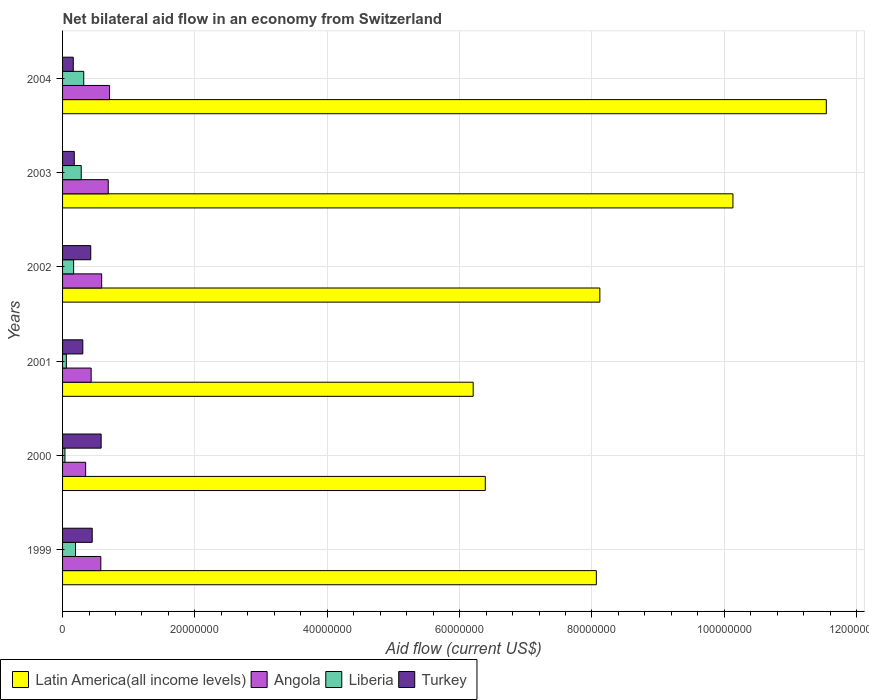How many bars are there on the 4th tick from the top?
Provide a short and direct response. 4. In how many cases, is the number of bars for a given year not equal to the number of legend labels?
Offer a terse response. 0. What is the net bilateral aid flow in Liberia in 2002?
Offer a terse response. 1.67e+06. Across all years, what is the maximum net bilateral aid flow in Angola?
Keep it short and to the point. 7.10e+06. Across all years, what is the minimum net bilateral aid flow in Angola?
Your response must be concise. 3.49e+06. In which year was the net bilateral aid flow in Angola maximum?
Offer a very short reply. 2004. In which year was the net bilateral aid flow in Angola minimum?
Offer a terse response. 2000. What is the total net bilateral aid flow in Angola in the graph?
Give a very brief answer. 3.35e+07. What is the difference between the net bilateral aid flow in Liberia in 2000 and that in 2004?
Offer a terse response. -2.84e+06. What is the difference between the net bilateral aid flow in Angola in 2004 and the net bilateral aid flow in Latin America(all income levels) in 1999?
Your answer should be compact. -7.36e+07. What is the average net bilateral aid flow in Angola per year?
Provide a succinct answer. 5.58e+06. In the year 1999, what is the difference between the net bilateral aid flow in Turkey and net bilateral aid flow in Latin America(all income levels)?
Your answer should be compact. -7.62e+07. What is the ratio of the net bilateral aid flow in Angola in 2002 to that in 2003?
Your answer should be compact. 0.86. Is the net bilateral aid flow in Turkey in 2002 less than that in 2004?
Your answer should be compact. No. Is the difference between the net bilateral aid flow in Turkey in 2003 and 2004 greater than the difference between the net bilateral aid flow in Latin America(all income levels) in 2003 and 2004?
Offer a terse response. Yes. What is the difference between the highest and the lowest net bilateral aid flow in Latin America(all income levels)?
Make the answer very short. 5.34e+07. In how many years, is the net bilateral aid flow in Liberia greater than the average net bilateral aid flow in Liberia taken over all years?
Ensure brevity in your answer.  3. Is it the case that in every year, the sum of the net bilateral aid flow in Angola and net bilateral aid flow in Latin America(all income levels) is greater than the sum of net bilateral aid flow in Turkey and net bilateral aid flow in Liberia?
Provide a succinct answer. No. What does the 4th bar from the top in 2002 represents?
Offer a very short reply. Latin America(all income levels). What does the 2nd bar from the bottom in 1999 represents?
Ensure brevity in your answer.  Angola. Is it the case that in every year, the sum of the net bilateral aid flow in Angola and net bilateral aid flow in Liberia is greater than the net bilateral aid flow in Turkey?
Ensure brevity in your answer.  No. How many bars are there?
Your answer should be very brief. 24. How many years are there in the graph?
Your answer should be compact. 6. What is the difference between two consecutive major ticks on the X-axis?
Provide a succinct answer. 2.00e+07. Are the values on the major ticks of X-axis written in scientific E-notation?
Give a very brief answer. No. Does the graph contain any zero values?
Give a very brief answer. No. How many legend labels are there?
Provide a short and direct response. 4. How are the legend labels stacked?
Keep it short and to the point. Horizontal. What is the title of the graph?
Your answer should be very brief. Net bilateral aid flow in an economy from Switzerland. What is the label or title of the Y-axis?
Your answer should be compact. Years. What is the Aid flow (current US$) in Latin America(all income levels) in 1999?
Give a very brief answer. 8.07e+07. What is the Aid flow (current US$) in Angola in 1999?
Offer a terse response. 5.78e+06. What is the Aid flow (current US$) in Liberia in 1999?
Ensure brevity in your answer.  1.96e+06. What is the Aid flow (current US$) in Turkey in 1999?
Your answer should be compact. 4.48e+06. What is the Aid flow (current US$) in Latin America(all income levels) in 2000?
Your answer should be very brief. 6.39e+07. What is the Aid flow (current US$) of Angola in 2000?
Give a very brief answer. 3.49e+06. What is the Aid flow (current US$) in Liberia in 2000?
Offer a terse response. 3.60e+05. What is the Aid flow (current US$) of Turkey in 2000?
Offer a very short reply. 5.83e+06. What is the Aid flow (current US$) in Latin America(all income levels) in 2001?
Give a very brief answer. 6.20e+07. What is the Aid flow (current US$) of Angola in 2001?
Provide a succinct answer. 4.32e+06. What is the Aid flow (current US$) in Liberia in 2001?
Provide a succinct answer. 5.70e+05. What is the Aid flow (current US$) in Turkey in 2001?
Give a very brief answer. 3.06e+06. What is the Aid flow (current US$) in Latin America(all income levels) in 2002?
Your answer should be very brief. 8.12e+07. What is the Aid flow (current US$) in Angola in 2002?
Ensure brevity in your answer.  5.91e+06. What is the Aid flow (current US$) of Liberia in 2002?
Keep it short and to the point. 1.67e+06. What is the Aid flow (current US$) in Turkey in 2002?
Keep it short and to the point. 4.26e+06. What is the Aid flow (current US$) of Latin America(all income levels) in 2003?
Give a very brief answer. 1.01e+08. What is the Aid flow (current US$) in Angola in 2003?
Your answer should be compact. 6.90e+06. What is the Aid flow (current US$) of Liberia in 2003?
Provide a short and direct response. 2.82e+06. What is the Aid flow (current US$) of Turkey in 2003?
Keep it short and to the point. 1.77e+06. What is the Aid flow (current US$) in Latin America(all income levels) in 2004?
Your answer should be compact. 1.15e+08. What is the Aid flow (current US$) of Angola in 2004?
Your answer should be compact. 7.10e+06. What is the Aid flow (current US$) of Liberia in 2004?
Give a very brief answer. 3.20e+06. What is the Aid flow (current US$) in Turkey in 2004?
Your response must be concise. 1.62e+06. Across all years, what is the maximum Aid flow (current US$) of Latin America(all income levels)?
Your response must be concise. 1.15e+08. Across all years, what is the maximum Aid flow (current US$) in Angola?
Provide a succinct answer. 7.10e+06. Across all years, what is the maximum Aid flow (current US$) in Liberia?
Keep it short and to the point. 3.20e+06. Across all years, what is the maximum Aid flow (current US$) in Turkey?
Your answer should be compact. 5.83e+06. Across all years, what is the minimum Aid flow (current US$) of Latin America(all income levels)?
Provide a succinct answer. 6.20e+07. Across all years, what is the minimum Aid flow (current US$) of Angola?
Provide a short and direct response. 3.49e+06. Across all years, what is the minimum Aid flow (current US$) of Liberia?
Offer a very short reply. 3.60e+05. Across all years, what is the minimum Aid flow (current US$) in Turkey?
Your answer should be compact. 1.62e+06. What is the total Aid flow (current US$) of Latin America(all income levels) in the graph?
Keep it short and to the point. 5.04e+08. What is the total Aid flow (current US$) of Angola in the graph?
Offer a terse response. 3.35e+07. What is the total Aid flow (current US$) in Liberia in the graph?
Offer a terse response. 1.06e+07. What is the total Aid flow (current US$) of Turkey in the graph?
Your answer should be compact. 2.10e+07. What is the difference between the Aid flow (current US$) in Latin America(all income levels) in 1999 and that in 2000?
Your answer should be very brief. 1.68e+07. What is the difference between the Aid flow (current US$) of Angola in 1999 and that in 2000?
Ensure brevity in your answer.  2.29e+06. What is the difference between the Aid flow (current US$) in Liberia in 1999 and that in 2000?
Your answer should be very brief. 1.60e+06. What is the difference between the Aid flow (current US$) of Turkey in 1999 and that in 2000?
Offer a very short reply. -1.35e+06. What is the difference between the Aid flow (current US$) of Latin America(all income levels) in 1999 and that in 2001?
Ensure brevity in your answer.  1.86e+07. What is the difference between the Aid flow (current US$) in Angola in 1999 and that in 2001?
Your response must be concise. 1.46e+06. What is the difference between the Aid flow (current US$) in Liberia in 1999 and that in 2001?
Offer a very short reply. 1.39e+06. What is the difference between the Aid flow (current US$) in Turkey in 1999 and that in 2001?
Ensure brevity in your answer.  1.42e+06. What is the difference between the Aid flow (current US$) in Latin America(all income levels) in 1999 and that in 2002?
Make the answer very short. -5.30e+05. What is the difference between the Aid flow (current US$) in Latin America(all income levels) in 1999 and that in 2003?
Provide a succinct answer. -2.06e+07. What is the difference between the Aid flow (current US$) in Angola in 1999 and that in 2003?
Make the answer very short. -1.12e+06. What is the difference between the Aid flow (current US$) of Liberia in 1999 and that in 2003?
Offer a terse response. -8.60e+05. What is the difference between the Aid flow (current US$) of Turkey in 1999 and that in 2003?
Your response must be concise. 2.71e+06. What is the difference between the Aid flow (current US$) in Latin America(all income levels) in 1999 and that in 2004?
Offer a terse response. -3.48e+07. What is the difference between the Aid flow (current US$) in Angola in 1999 and that in 2004?
Your answer should be compact. -1.32e+06. What is the difference between the Aid flow (current US$) in Liberia in 1999 and that in 2004?
Offer a terse response. -1.24e+06. What is the difference between the Aid flow (current US$) in Turkey in 1999 and that in 2004?
Give a very brief answer. 2.86e+06. What is the difference between the Aid flow (current US$) in Latin America(all income levels) in 2000 and that in 2001?
Your answer should be compact. 1.83e+06. What is the difference between the Aid flow (current US$) in Angola in 2000 and that in 2001?
Your response must be concise. -8.30e+05. What is the difference between the Aid flow (current US$) in Liberia in 2000 and that in 2001?
Provide a succinct answer. -2.10e+05. What is the difference between the Aid flow (current US$) of Turkey in 2000 and that in 2001?
Give a very brief answer. 2.77e+06. What is the difference between the Aid flow (current US$) in Latin America(all income levels) in 2000 and that in 2002?
Your response must be concise. -1.73e+07. What is the difference between the Aid flow (current US$) in Angola in 2000 and that in 2002?
Provide a succinct answer. -2.42e+06. What is the difference between the Aid flow (current US$) of Liberia in 2000 and that in 2002?
Provide a short and direct response. -1.31e+06. What is the difference between the Aid flow (current US$) of Turkey in 2000 and that in 2002?
Keep it short and to the point. 1.57e+06. What is the difference between the Aid flow (current US$) of Latin America(all income levels) in 2000 and that in 2003?
Your answer should be compact. -3.74e+07. What is the difference between the Aid flow (current US$) in Angola in 2000 and that in 2003?
Offer a very short reply. -3.41e+06. What is the difference between the Aid flow (current US$) in Liberia in 2000 and that in 2003?
Give a very brief answer. -2.46e+06. What is the difference between the Aid flow (current US$) in Turkey in 2000 and that in 2003?
Make the answer very short. 4.06e+06. What is the difference between the Aid flow (current US$) in Latin America(all income levels) in 2000 and that in 2004?
Ensure brevity in your answer.  -5.15e+07. What is the difference between the Aid flow (current US$) of Angola in 2000 and that in 2004?
Make the answer very short. -3.61e+06. What is the difference between the Aid flow (current US$) of Liberia in 2000 and that in 2004?
Provide a short and direct response. -2.84e+06. What is the difference between the Aid flow (current US$) of Turkey in 2000 and that in 2004?
Offer a very short reply. 4.21e+06. What is the difference between the Aid flow (current US$) in Latin America(all income levels) in 2001 and that in 2002?
Give a very brief answer. -1.91e+07. What is the difference between the Aid flow (current US$) in Angola in 2001 and that in 2002?
Make the answer very short. -1.59e+06. What is the difference between the Aid flow (current US$) in Liberia in 2001 and that in 2002?
Offer a very short reply. -1.10e+06. What is the difference between the Aid flow (current US$) in Turkey in 2001 and that in 2002?
Offer a terse response. -1.20e+06. What is the difference between the Aid flow (current US$) in Latin America(all income levels) in 2001 and that in 2003?
Ensure brevity in your answer.  -3.92e+07. What is the difference between the Aid flow (current US$) of Angola in 2001 and that in 2003?
Your answer should be very brief. -2.58e+06. What is the difference between the Aid flow (current US$) in Liberia in 2001 and that in 2003?
Offer a very short reply. -2.25e+06. What is the difference between the Aid flow (current US$) in Turkey in 2001 and that in 2003?
Your response must be concise. 1.29e+06. What is the difference between the Aid flow (current US$) of Latin America(all income levels) in 2001 and that in 2004?
Offer a terse response. -5.34e+07. What is the difference between the Aid flow (current US$) of Angola in 2001 and that in 2004?
Provide a succinct answer. -2.78e+06. What is the difference between the Aid flow (current US$) in Liberia in 2001 and that in 2004?
Your answer should be compact. -2.63e+06. What is the difference between the Aid flow (current US$) in Turkey in 2001 and that in 2004?
Provide a short and direct response. 1.44e+06. What is the difference between the Aid flow (current US$) of Latin America(all income levels) in 2002 and that in 2003?
Ensure brevity in your answer.  -2.01e+07. What is the difference between the Aid flow (current US$) in Angola in 2002 and that in 2003?
Offer a very short reply. -9.90e+05. What is the difference between the Aid flow (current US$) of Liberia in 2002 and that in 2003?
Keep it short and to the point. -1.15e+06. What is the difference between the Aid flow (current US$) in Turkey in 2002 and that in 2003?
Your answer should be compact. 2.49e+06. What is the difference between the Aid flow (current US$) in Latin America(all income levels) in 2002 and that in 2004?
Provide a short and direct response. -3.42e+07. What is the difference between the Aid flow (current US$) of Angola in 2002 and that in 2004?
Ensure brevity in your answer.  -1.19e+06. What is the difference between the Aid flow (current US$) in Liberia in 2002 and that in 2004?
Keep it short and to the point. -1.53e+06. What is the difference between the Aid flow (current US$) in Turkey in 2002 and that in 2004?
Your response must be concise. 2.64e+06. What is the difference between the Aid flow (current US$) in Latin America(all income levels) in 2003 and that in 2004?
Provide a short and direct response. -1.41e+07. What is the difference between the Aid flow (current US$) of Angola in 2003 and that in 2004?
Offer a terse response. -2.00e+05. What is the difference between the Aid flow (current US$) of Liberia in 2003 and that in 2004?
Your response must be concise. -3.80e+05. What is the difference between the Aid flow (current US$) in Latin America(all income levels) in 1999 and the Aid flow (current US$) in Angola in 2000?
Provide a short and direct response. 7.72e+07. What is the difference between the Aid flow (current US$) of Latin America(all income levels) in 1999 and the Aid flow (current US$) of Liberia in 2000?
Provide a short and direct response. 8.03e+07. What is the difference between the Aid flow (current US$) in Latin America(all income levels) in 1999 and the Aid flow (current US$) in Turkey in 2000?
Your answer should be very brief. 7.48e+07. What is the difference between the Aid flow (current US$) in Angola in 1999 and the Aid flow (current US$) in Liberia in 2000?
Your response must be concise. 5.42e+06. What is the difference between the Aid flow (current US$) of Angola in 1999 and the Aid flow (current US$) of Turkey in 2000?
Keep it short and to the point. -5.00e+04. What is the difference between the Aid flow (current US$) in Liberia in 1999 and the Aid flow (current US$) in Turkey in 2000?
Your answer should be very brief. -3.87e+06. What is the difference between the Aid flow (current US$) in Latin America(all income levels) in 1999 and the Aid flow (current US$) in Angola in 2001?
Provide a succinct answer. 7.63e+07. What is the difference between the Aid flow (current US$) of Latin America(all income levels) in 1999 and the Aid flow (current US$) of Liberia in 2001?
Provide a short and direct response. 8.01e+07. What is the difference between the Aid flow (current US$) of Latin America(all income levels) in 1999 and the Aid flow (current US$) of Turkey in 2001?
Provide a succinct answer. 7.76e+07. What is the difference between the Aid flow (current US$) of Angola in 1999 and the Aid flow (current US$) of Liberia in 2001?
Offer a very short reply. 5.21e+06. What is the difference between the Aid flow (current US$) in Angola in 1999 and the Aid flow (current US$) in Turkey in 2001?
Offer a very short reply. 2.72e+06. What is the difference between the Aid flow (current US$) in Liberia in 1999 and the Aid flow (current US$) in Turkey in 2001?
Make the answer very short. -1.10e+06. What is the difference between the Aid flow (current US$) of Latin America(all income levels) in 1999 and the Aid flow (current US$) of Angola in 2002?
Your answer should be compact. 7.48e+07. What is the difference between the Aid flow (current US$) of Latin America(all income levels) in 1999 and the Aid flow (current US$) of Liberia in 2002?
Provide a short and direct response. 7.90e+07. What is the difference between the Aid flow (current US$) of Latin America(all income levels) in 1999 and the Aid flow (current US$) of Turkey in 2002?
Your response must be concise. 7.64e+07. What is the difference between the Aid flow (current US$) in Angola in 1999 and the Aid flow (current US$) in Liberia in 2002?
Provide a succinct answer. 4.11e+06. What is the difference between the Aid flow (current US$) in Angola in 1999 and the Aid flow (current US$) in Turkey in 2002?
Offer a very short reply. 1.52e+06. What is the difference between the Aid flow (current US$) of Liberia in 1999 and the Aid flow (current US$) of Turkey in 2002?
Ensure brevity in your answer.  -2.30e+06. What is the difference between the Aid flow (current US$) in Latin America(all income levels) in 1999 and the Aid flow (current US$) in Angola in 2003?
Give a very brief answer. 7.38e+07. What is the difference between the Aid flow (current US$) in Latin America(all income levels) in 1999 and the Aid flow (current US$) in Liberia in 2003?
Ensure brevity in your answer.  7.78e+07. What is the difference between the Aid flow (current US$) of Latin America(all income levels) in 1999 and the Aid flow (current US$) of Turkey in 2003?
Offer a terse response. 7.89e+07. What is the difference between the Aid flow (current US$) in Angola in 1999 and the Aid flow (current US$) in Liberia in 2003?
Ensure brevity in your answer.  2.96e+06. What is the difference between the Aid flow (current US$) of Angola in 1999 and the Aid flow (current US$) of Turkey in 2003?
Offer a terse response. 4.01e+06. What is the difference between the Aid flow (current US$) of Liberia in 1999 and the Aid flow (current US$) of Turkey in 2003?
Offer a terse response. 1.90e+05. What is the difference between the Aid flow (current US$) in Latin America(all income levels) in 1999 and the Aid flow (current US$) in Angola in 2004?
Provide a succinct answer. 7.36e+07. What is the difference between the Aid flow (current US$) of Latin America(all income levels) in 1999 and the Aid flow (current US$) of Liberia in 2004?
Make the answer very short. 7.75e+07. What is the difference between the Aid flow (current US$) of Latin America(all income levels) in 1999 and the Aid flow (current US$) of Turkey in 2004?
Offer a very short reply. 7.90e+07. What is the difference between the Aid flow (current US$) in Angola in 1999 and the Aid flow (current US$) in Liberia in 2004?
Make the answer very short. 2.58e+06. What is the difference between the Aid flow (current US$) of Angola in 1999 and the Aid flow (current US$) of Turkey in 2004?
Give a very brief answer. 4.16e+06. What is the difference between the Aid flow (current US$) in Latin America(all income levels) in 2000 and the Aid flow (current US$) in Angola in 2001?
Keep it short and to the point. 5.96e+07. What is the difference between the Aid flow (current US$) of Latin America(all income levels) in 2000 and the Aid flow (current US$) of Liberia in 2001?
Keep it short and to the point. 6.33e+07. What is the difference between the Aid flow (current US$) of Latin America(all income levels) in 2000 and the Aid flow (current US$) of Turkey in 2001?
Provide a short and direct response. 6.08e+07. What is the difference between the Aid flow (current US$) of Angola in 2000 and the Aid flow (current US$) of Liberia in 2001?
Ensure brevity in your answer.  2.92e+06. What is the difference between the Aid flow (current US$) in Angola in 2000 and the Aid flow (current US$) in Turkey in 2001?
Offer a terse response. 4.30e+05. What is the difference between the Aid flow (current US$) of Liberia in 2000 and the Aid flow (current US$) of Turkey in 2001?
Offer a terse response. -2.70e+06. What is the difference between the Aid flow (current US$) in Latin America(all income levels) in 2000 and the Aid flow (current US$) in Angola in 2002?
Ensure brevity in your answer.  5.80e+07. What is the difference between the Aid flow (current US$) in Latin America(all income levels) in 2000 and the Aid flow (current US$) in Liberia in 2002?
Your response must be concise. 6.22e+07. What is the difference between the Aid flow (current US$) of Latin America(all income levels) in 2000 and the Aid flow (current US$) of Turkey in 2002?
Give a very brief answer. 5.96e+07. What is the difference between the Aid flow (current US$) in Angola in 2000 and the Aid flow (current US$) in Liberia in 2002?
Provide a succinct answer. 1.82e+06. What is the difference between the Aid flow (current US$) of Angola in 2000 and the Aid flow (current US$) of Turkey in 2002?
Offer a very short reply. -7.70e+05. What is the difference between the Aid flow (current US$) of Liberia in 2000 and the Aid flow (current US$) of Turkey in 2002?
Your answer should be very brief. -3.90e+06. What is the difference between the Aid flow (current US$) in Latin America(all income levels) in 2000 and the Aid flow (current US$) in Angola in 2003?
Make the answer very short. 5.70e+07. What is the difference between the Aid flow (current US$) of Latin America(all income levels) in 2000 and the Aid flow (current US$) of Liberia in 2003?
Your answer should be very brief. 6.11e+07. What is the difference between the Aid flow (current US$) of Latin America(all income levels) in 2000 and the Aid flow (current US$) of Turkey in 2003?
Offer a terse response. 6.21e+07. What is the difference between the Aid flow (current US$) in Angola in 2000 and the Aid flow (current US$) in Liberia in 2003?
Offer a very short reply. 6.70e+05. What is the difference between the Aid flow (current US$) of Angola in 2000 and the Aid flow (current US$) of Turkey in 2003?
Make the answer very short. 1.72e+06. What is the difference between the Aid flow (current US$) of Liberia in 2000 and the Aid flow (current US$) of Turkey in 2003?
Your answer should be very brief. -1.41e+06. What is the difference between the Aid flow (current US$) of Latin America(all income levels) in 2000 and the Aid flow (current US$) of Angola in 2004?
Provide a short and direct response. 5.68e+07. What is the difference between the Aid flow (current US$) in Latin America(all income levels) in 2000 and the Aid flow (current US$) in Liberia in 2004?
Your answer should be very brief. 6.07e+07. What is the difference between the Aid flow (current US$) in Latin America(all income levels) in 2000 and the Aid flow (current US$) in Turkey in 2004?
Offer a very short reply. 6.23e+07. What is the difference between the Aid flow (current US$) in Angola in 2000 and the Aid flow (current US$) in Turkey in 2004?
Your answer should be compact. 1.87e+06. What is the difference between the Aid flow (current US$) of Liberia in 2000 and the Aid flow (current US$) of Turkey in 2004?
Give a very brief answer. -1.26e+06. What is the difference between the Aid flow (current US$) of Latin America(all income levels) in 2001 and the Aid flow (current US$) of Angola in 2002?
Offer a terse response. 5.61e+07. What is the difference between the Aid flow (current US$) in Latin America(all income levels) in 2001 and the Aid flow (current US$) in Liberia in 2002?
Your response must be concise. 6.04e+07. What is the difference between the Aid flow (current US$) in Latin America(all income levels) in 2001 and the Aid flow (current US$) in Turkey in 2002?
Your answer should be compact. 5.78e+07. What is the difference between the Aid flow (current US$) of Angola in 2001 and the Aid flow (current US$) of Liberia in 2002?
Your answer should be very brief. 2.65e+06. What is the difference between the Aid flow (current US$) in Liberia in 2001 and the Aid flow (current US$) in Turkey in 2002?
Provide a succinct answer. -3.69e+06. What is the difference between the Aid flow (current US$) in Latin America(all income levels) in 2001 and the Aid flow (current US$) in Angola in 2003?
Provide a succinct answer. 5.52e+07. What is the difference between the Aid flow (current US$) of Latin America(all income levels) in 2001 and the Aid flow (current US$) of Liberia in 2003?
Give a very brief answer. 5.92e+07. What is the difference between the Aid flow (current US$) in Latin America(all income levels) in 2001 and the Aid flow (current US$) in Turkey in 2003?
Provide a short and direct response. 6.03e+07. What is the difference between the Aid flow (current US$) in Angola in 2001 and the Aid flow (current US$) in Liberia in 2003?
Ensure brevity in your answer.  1.50e+06. What is the difference between the Aid flow (current US$) in Angola in 2001 and the Aid flow (current US$) in Turkey in 2003?
Your answer should be compact. 2.55e+06. What is the difference between the Aid flow (current US$) in Liberia in 2001 and the Aid flow (current US$) in Turkey in 2003?
Your response must be concise. -1.20e+06. What is the difference between the Aid flow (current US$) in Latin America(all income levels) in 2001 and the Aid flow (current US$) in Angola in 2004?
Offer a very short reply. 5.50e+07. What is the difference between the Aid flow (current US$) of Latin America(all income levels) in 2001 and the Aid flow (current US$) of Liberia in 2004?
Provide a succinct answer. 5.88e+07. What is the difference between the Aid flow (current US$) in Latin America(all income levels) in 2001 and the Aid flow (current US$) in Turkey in 2004?
Offer a very short reply. 6.04e+07. What is the difference between the Aid flow (current US$) in Angola in 2001 and the Aid flow (current US$) in Liberia in 2004?
Your response must be concise. 1.12e+06. What is the difference between the Aid flow (current US$) of Angola in 2001 and the Aid flow (current US$) of Turkey in 2004?
Your answer should be compact. 2.70e+06. What is the difference between the Aid flow (current US$) of Liberia in 2001 and the Aid flow (current US$) of Turkey in 2004?
Make the answer very short. -1.05e+06. What is the difference between the Aid flow (current US$) of Latin America(all income levels) in 2002 and the Aid flow (current US$) of Angola in 2003?
Offer a very short reply. 7.43e+07. What is the difference between the Aid flow (current US$) of Latin America(all income levels) in 2002 and the Aid flow (current US$) of Liberia in 2003?
Your response must be concise. 7.84e+07. What is the difference between the Aid flow (current US$) of Latin America(all income levels) in 2002 and the Aid flow (current US$) of Turkey in 2003?
Offer a very short reply. 7.94e+07. What is the difference between the Aid flow (current US$) of Angola in 2002 and the Aid flow (current US$) of Liberia in 2003?
Offer a very short reply. 3.09e+06. What is the difference between the Aid flow (current US$) in Angola in 2002 and the Aid flow (current US$) in Turkey in 2003?
Keep it short and to the point. 4.14e+06. What is the difference between the Aid flow (current US$) of Liberia in 2002 and the Aid flow (current US$) of Turkey in 2003?
Give a very brief answer. -1.00e+05. What is the difference between the Aid flow (current US$) in Latin America(all income levels) in 2002 and the Aid flow (current US$) in Angola in 2004?
Ensure brevity in your answer.  7.41e+07. What is the difference between the Aid flow (current US$) of Latin America(all income levels) in 2002 and the Aid flow (current US$) of Liberia in 2004?
Make the answer very short. 7.80e+07. What is the difference between the Aid flow (current US$) of Latin America(all income levels) in 2002 and the Aid flow (current US$) of Turkey in 2004?
Offer a very short reply. 7.96e+07. What is the difference between the Aid flow (current US$) in Angola in 2002 and the Aid flow (current US$) in Liberia in 2004?
Provide a short and direct response. 2.71e+06. What is the difference between the Aid flow (current US$) in Angola in 2002 and the Aid flow (current US$) in Turkey in 2004?
Your answer should be very brief. 4.29e+06. What is the difference between the Aid flow (current US$) of Latin America(all income levels) in 2003 and the Aid flow (current US$) of Angola in 2004?
Your answer should be very brief. 9.42e+07. What is the difference between the Aid flow (current US$) in Latin America(all income levels) in 2003 and the Aid flow (current US$) in Liberia in 2004?
Give a very brief answer. 9.81e+07. What is the difference between the Aid flow (current US$) in Latin America(all income levels) in 2003 and the Aid flow (current US$) in Turkey in 2004?
Keep it short and to the point. 9.97e+07. What is the difference between the Aid flow (current US$) of Angola in 2003 and the Aid flow (current US$) of Liberia in 2004?
Offer a very short reply. 3.70e+06. What is the difference between the Aid flow (current US$) in Angola in 2003 and the Aid flow (current US$) in Turkey in 2004?
Your response must be concise. 5.28e+06. What is the difference between the Aid flow (current US$) in Liberia in 2003 and the Aid flow (current US$) in Turkey in 2004?
Ensure brevity in your answer.  1.20e+06. What is the average Aid flow (current US$) of Latin America(all income levels) per year?
Offer a very short reply. 8.41e+07. What is the average Aid flow (current US$) in Angola per year?
Give a very brief answer. 5.58e+06. What is the average Aid flow (current US$) in Liberia per year?
Offer a very short reply. 1.76e+06. What is the average Aid flow (current US$) in Turkey per year?
Your answer should be compact. 3.50e+06. In the year 1999, what is the difference between the Aid flow (current US$) in Latin America(all income levels) and Aid flow (current US$) in Angola?
Provide a succinct answer. 7.49e+07. In the year 1999, what is the difference between the Aid flow (current US$) of Latin America(all income levels) and Aid flow (current US$) of Liberia?
Your answer should be very brief. 7.87e+07. In the year 1999, what is the difference between the Aid flow (current US$) in Latin America(all income levels) and Aid flow (current US$) in Turkey?
Offer a very short reply. 7.62e+07. In the year 1999, what is the difference between the Aid flow (current US$) in Angola and Aid flow (current US$) in Liberia?
Ensure brevity in your answer.  3.82e+06. In the year 1999, what is the difference between the Aid flow (current US$) of Angola and Aid flow (current US$) of Turkey?
Give a very brief answer. 1.30e+06. In the year 1999, what is the difference between the Aid flow (current US$) in Liberia and Aid flow (current US$) in Turkey?
Give a very brief answer. -2.52e+06. In the year 2000, what is the difference between the Aid flow (current US$) in Latin America(all income levels) and Aid flow (current US$) in Angola?
Provide a short and direct response. 6.04e+07. In the year 2000, what is the difference between the Aid flow (current US$) of Latin America(all income levels) and Aid flow (current US$) of Liberia?
Offer a very short reply. 6.35e+07. In the year 2000, what is the difference between the Aid flow (current US$) of Latin America(all income levels) and Aid flow (current US$) of Turkey?
Provide a short and direct response. 5.80e+07. In the year 2000, what is the difference between the Aid flow (current US$) of Angola and Aid flow (current US$) of Liberia?
Offer a terse response. 3.13e+06. In the year 2000, what is the difference between the Aid flow (current US$) of Angola and Aid flow (current US$) of Turkey?
Provide a succinct answer. -2.34e+06. In the year 2000, what is the difference between the Aid flow (current US$) of Liberia and Aid flow (current US$) of Turkey?
Offer a very short reply. -5.47e+06. In the year 2001, what is the difference between the Aid flow (current US$) in Latin America(all income levels) and Aid flow (current US$) in Angola?
Ensure brevity in your answer.  5.77e+07. In the year 2001, what is the difference between the Aid flow (current US$) in Latin America(all income levels) and Aid flow (current US$) in Liberia?
Your answer should be very brief. 6.15e+07. In the year 2001, what is the difference between the Aid flow (current US$) in Latin America(all income levels) and Aid flow (current US$) in Turkey?
Provide a short and direct response. 5.90e+07. In the year 2001, what is the difference between the Aid flow (current US$) in Angola and Aid flow (current US$) in Liberia?
Offer a terse response. 3.75e+06. In the year 2001, what is the difference between the Aid flow (current US$) of Angola and Aid flow (current US$) of Turkey?
Your answer should be very brief. 1.26e+06. In the year 2001, what is the difference between the Aid flow (current US$) in Liberia and Aid flow (current US$) in Turkey?
Ensure brevity in your answer.  -2.49e+06. In the year 2002, what is the difference between the Aid flow (current US$) of Latin America(all income levels) and Aid flow (current US$) of Angola?
Keep it short and to the point. 7.53e+07. In the year 2002, what is the difference between the Aid flow (current US$) in Latin America(all income levels) and Aid flow (current US$) in Liberia?
Your response must be concise. 7.95e+07. In the year 2002, what is the difference between the Aid flow (current US$) in Latin America(all income levels) and Aid flow (current US$) in Turkey?
Your answer should be compact. 7.69e+07. In the year 2002, what is the difference between the Aid flow (current US$) of Angola and Aid flow (current US$) of Liberia?
Provide a short and direct response. 4.24e+06. In the year 2002, what is the difference between the Aid flow (current US$) of Angola and Aid flow (current US$) of Turkey?
Offer a terse response. 1.65e+06. In the year 2002, what is the difference between the Aid flow (current US$) of Liberia and Aid flow (current US$) of Turkey?
Provide a succinct answer. -2.59e+06. In the year 2003, what is the difference between the Aid flow (current US$) in Latin America(all income levels) and Aid flow (current US$) in Angola?
Ensure brevity in your answer.  9.44e+07. In the year 2003, what is the difference between the Aid flow (current US$) of Latin America(all income levels) and Aid flow (current US$) of Liberia?
Provide a short and direct response. 9.85e+07. In the year 2003, what is the difference between the Aid flow (current US$) of Latin America(all income levels) and Aid flow (current US$) of Turkey?
Your answer should be compact. 9.95e+07. In the year 2003, what is the difference between the Aid flow (current US$) of Angola and Aid flow (current US$) of Liberia?
Offer a terse response. 4.08e+06. In the year 2003, what is the difference between the Aid flow (current US$) in Angola and Aid flow (current US$) in Turkey?
Offer a very short reply. 5.13e+06. In the year 2003, what is the difference between the Aid flow (current US$) of Liberia and Aid flow (current US$) of Turkey?
Offer a very short reply. 1.05e+06. In the year 2004, what is the difference between the Aid flow (current US$) in Latin America(all income levels) and Aid flow (current US$) in Angola?
Your answer should be compact. 1.08e+08. In the year 2004, what is the difference between the Aid flow (current US$) of Latin America(all income levels) and Aid flow (current US$) of Liberia?
Make the answer very short. 1.12e+08. In the year 2004, what is the difference between the Aid flow (current US$) in Latin America(all income levels) and Aid flow (current US$) in Turkey?
Your answer should be compact. 1.14e+08. In the year 2004, what is the difference between the Aid flow (current US$) of Angola and Aid flow (current US$) of Liberia?
Keep it short and to the point. 3.90e+06. In the year 2004, what is the difference between the Aid flow (current US$) of Angola and Aid flow (current US$) of Turkey?
Offer a terse response. 5.48e+06. In the year 2004, what is the difference between the Aid flow (current US$) in Liberia and Aid flow (current US$) in Turkey?
Give a very brief answer. 1.58e+06. What is the ratio of the Aid flow (current US$) of Latin America(all income levels) in 1999 to that in 2000?
Your answer should be very brief. 1.26. What is the ratio of the Aid flow (current US$) in Angola in 1999 to that in 2000?
Your answer should be very brief. 1.66. What is the ratio of the Aid flow (current US$) in Liberia in 1999 to that in 2000?
Ensure brevity in your answer.  5.44. What is the ratio of the Aid flow (current US$) of Turkey in 1999 to that in 2000?
Offer a terse response. 0.77. What is the ratio of the Aid flow (current US$) of Latin America(all income levels) in 1999 to that in 2001?
Ensure brevity in your answer.  1.3. What is the ratio of the Aid flow (current US$) in Angola in 1999 to that in 2001?
Offer a very short reply. 1.34. What is the ratio of the Aid flow (current US$) of Liberia in 1999 to that in 2001?
Your response must be concise. 3.44. What is the ratio of the Aid flow (current US$) of Turkey in 1999 to that in 2001?
Offer a very short reply. 1.46. What is the ratio of the Aid flow (current US$) of Latin America(all income levels) in 1999 to that in 2002?
Give a very brief answer. 0.99. What is the ratio of the Aid flow (current US$) in Angola in 1999 to that in 2002?
Give a very brief answer. 0.98. What is the ratio of the Aid flow (current US$) of Liberia in 1999 to that in 2002?
Provide a succinct answer. 1.17. What is the ratio of the Aid flow (current US$) of Turkey in 1999 to that in 2002?
Offer a terse response. 1.05. What is the ratio of the Aid flow (current US$) of Latin America(all income levels) in 1999 to that in 2003?
Provide a short and direct response. 0.8. What is the ratio of the Aid flow (current US$) of Angola in 1999 to that in 2003?
Give a very brief answer. 0.84. What is the ratio of the Aid flow (current US$) in Liberia in 1999 to that in 2003?
Offer a very short reply. 0.69. What is the ratio of the Aid flow (current US$) of Turkey in 1999 to that in 2003?
Provide a short and direct response. 2.53. What is the ratio of the Aid flow (current US$) of Latin America(all income levels) in 1999 to that in 2004?
Offer a terse response. 0.7. What is the ratio of the Aid flow (current US$) in Angola in 1999 to that in 2004?
Offer a very short reply. 0.81. What is the ratio of the Aid flow (current US$) of Liberia in 1999 to that in 2004?
Offer a terse response. 0.61. What is the ratio of the Aid flow (current US$) in Turkey in 1999 to that in 2004?
Offer a terse response. 2.77. What is the ratio of the Aid flow (current US$) in Latin America(all income levels) in 2000 to that in 2001?
Your answer should be very brief. 1.03. What is the ratio of the Aid flow (current US$) in Angola in 2000 to that in 2001?
Offer a very short reply. 0.81. What is the ratio of the Aid flow (current US$) in Liberia in 2000 to that in 2001?
Offer a very short reply. 0.63. What is the ratio of the Aid flow (current US$) of Turkey in 2000 to that in 2001?
Your answer should be very brief. 1.91. What is the ratio of the Aid flow (current US$) of Latin America(all income levels) in 2000 to that in 2002?
Give a very brief answer. 0.79. What is the ratio of the Aid flow (current US$) of Angola in 2000 to that in 2002?
Offer a very short reply. 0.59. What is the ratio of the Aid flow (current US$) in Liberia in 2000 to that in 2002?
Provide a succinct answer. 0.22. What is the ratio of the Aid flow (current US$) in Turkey in 2000 to that in 2002?
Provide a short and direct response. 1.37. What is the ratio of the Aid flow (current US$) of Latin America(all income levels) in 2000 to that in 2003?
Make the answer very short. 0.63. What is the ratio of the Aid flow (current US$) of Angola in 2000 to that in 2003?
Your response must be concise. 0.51. What is the ratio of the Aid flow (current US$) in Liberia in 2000 to that in 2003?
Provide a short and direct response. 0.13. What is the ratio of the Aid flow (current US$) of Turkey in 2000 to that in 2003?
Your answer should be compact. 3.29. What is the ratio of the Aid flow (current US$) in Latin America(all income levels) in 2000 to that in 2004?
Offer a very short reply. 0.55. What is the ratio of the Aid flow (current US$) in Angola in 2000 to that in 2004?
Provide a short and direct response. 0.49. What is the ratio of the Aid flow (current US$) of Liberia in 2000 to that in 2004?
Keep it short and to the point. 0.11. What is the ratio of the Aid flow (current US$) of Turkey in 2000 to that in 2004?
Make the answer very short. 3.6. What is the ratio of the Aid flow (current US$) in Latin America(all income levels) in 2001 to that in 2002?
Provide a succinct answer. 0.76. What is the ratio of the Aid flow (current US$) in Angola in 2001 to that in 2002?
Offer a very short reply. 0.73. What is the ratio of the Aid flow (current US$) of Liberia in 2001 to that in 2002?
Your response must be concise. 0.34. What is the ratio of the Aid flow (current US$) of Turkey in 2001 to that in 2002?
Ensure brevity in your answer.  0.72. What is the ratio of the Aid flow (current US$) of Latin America(all income levels) in 2001 to that in 2003?
Your answer should be compact. 0.61. What is the ratio of the Aid flow (current US$) in Angola in 2001 to that in 2003?
Provide a succinct answer. 0.63. What is the ratio of the Aid flow (current US$) of Liberia in 2001 to that in 2003?
Provide a short and direct response. 0.2. What is the ratio of the Aid flow (current US$) of Turkey in 2001 to that in 2003?
Provide a succinct answer. 1.73. What is the ratio of the Aid flow (current US$) of Latin America(all income levels) in 2001 to that in 2004?
Your answer should be very brief. 0.54. What is the ratio of the Aid flow (current US$) in Angola in 2001 to that in 2004?
Provide a short and direct response. 0.61. What is the ratio of the Aid flow (current US$) in Liberia in 2001 to that in 2004?
Make the answer very short. 0.18. What is the ratio of the Aid flow (current US$) of Turkey in 2001 to that in 2004?
Make the answer very short. 1.89. What is the ratio of the Aid flow (current US$) in Latin America(all income levels) in 2002 to that in 2003?
Offer a very short reply. 0.8. What is the ratio of the Aid flow (current US$) in Angola in 2002 to that in 2003?
Provide a succinct answer. 0.86. What is the ratio of the Aid flow (current US$) of Liberia in 2002 to that in 2003?
Ensure brevity in your answer.  0.59. What is the ratio of the Aid flow (current US$) of Turkey in 2002 to that in 2003?
Make the answer very short. 2.41. What is the ratio of the Aid flow (current US$) of Latin America(all income levels) in 2002 to that in 2004?
Provide a short and direct response. 0.7. What is the ratio of the Aid flow (current US$) of Angola in 2002 to that in 2004?
Provide a short and direct response. 0.83. What is the ratio of the Aid flow (current US$) of Liberia in 2002 to that in 2004?
Offer a very short reply. 0.52. What is the ratio of the Aid flow (current US$) of Turkey in 2002 to that in 2004?
Provide a succinct answer. 2.63. What is the ratio of the Aid flow (current US$) in Latin America(all income levels) in 2003 to that in 2004?
Provide a short and direct response. 0.88. What is the ratio of the Aid flow (current US$) of Angola in 2003 to that in 2004?
Provide a succinct answer. 0.97. What is the ratio of the Aid flow (current US$) of Liberia in 2003 to that in 2004?
Offer a very short reply. 0.88. What is the ratio of the Aid flow (current US$) in Turkey in 2003 to that in 2004?
Keep it short and to the point. 1.09. What is the difference between the highest and the second highest Aid flow (current US$) of Latin America(all income levels)?
Ensure brevity in your answer.  1.41e+07. What is the difference between the highest and the second highest Aid flow (current US$) of Angola?
Keep it short and to the point. 2.00e+05. What is the difference between the highest and the second highest Aid flow (current US$) in Turkey?
Ensure brevity in your answer.  1.35e+06. What is the difference between the highest and the lowest Aid flow (current US$) in Latin America(all income levels)?
Ensure brevity in your answer.  5.34e+07. What is the difference between the highest and the lowest Aid flow (current US$) in Angola?
Provide a short and direct response. 3.61e+06. What is the difference between the highest and the lowest Aid flow (current US$) of Liberia?
Offer a very short reply. 2.84e+06. What is the difference between the highest and the lowest Aid flow (current US$) in Turkey?
Your answer should be very brief. 4.21e+06. 